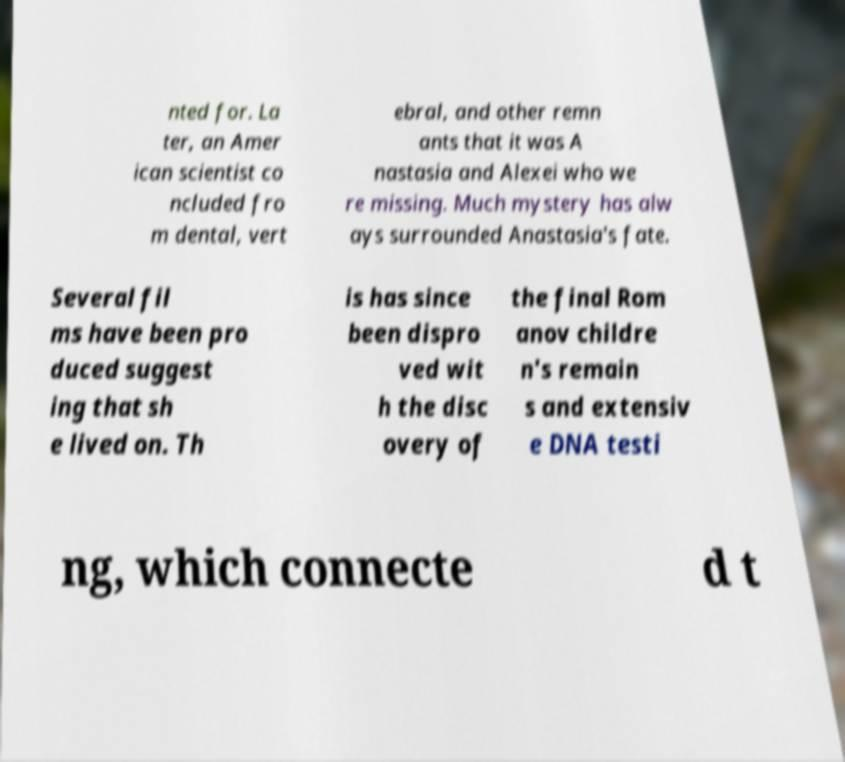What messages or text are displayed in this image? I need them in a readable, typed format. nted for. La ter, an Amer ican scientist co ncluded fro m dental, vert ebral, and other remn ants that it was A nastasia and Alexei who we re missing. Much mystery has alw ays surrounded Anastasia's fate. Several fil ms have been pro duced suggest ing that sh e lived on. Th is has since been dispro ved wit h the disc overy of the final Rom anov childre n's remain s and extensiv e DNA testi ng, which connecte d t 